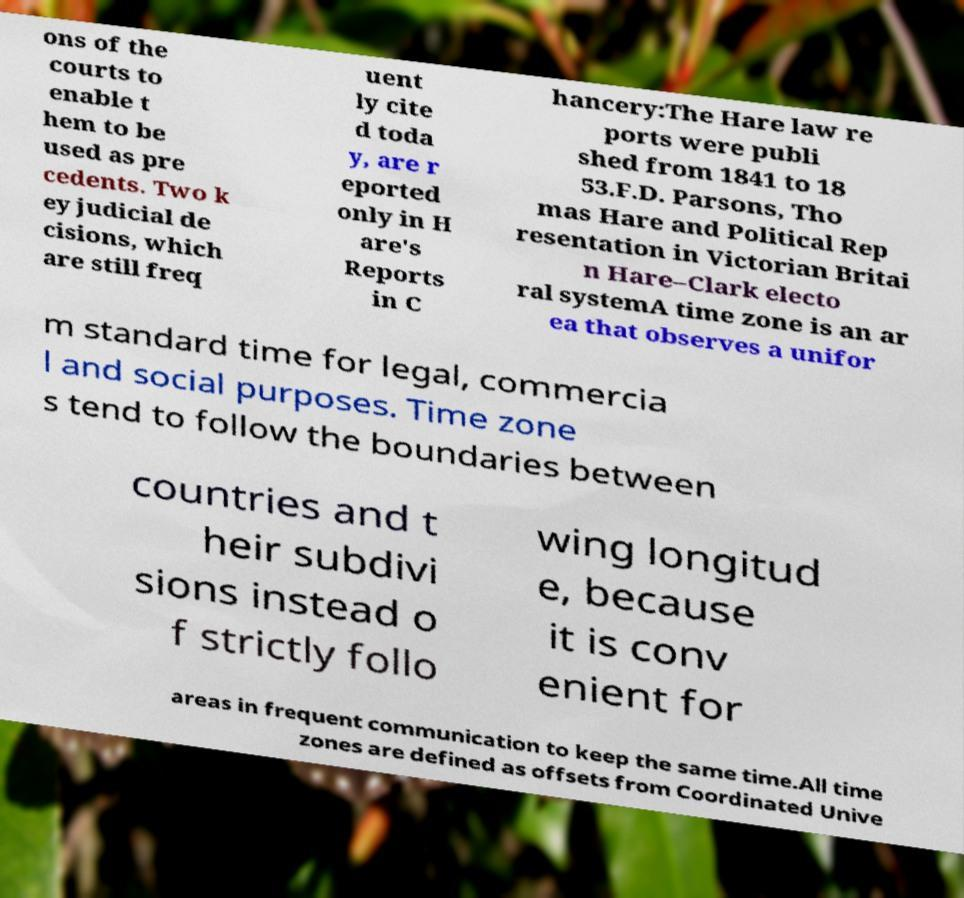I need the written content from this picture converted into text. Can you do that? ons of the courts to enable t hem to be used as pre cedents. Two k ey judicial de cisions, which are still freq uent ly cite d toda y, are r eported only in H are's Reports in C hancery:The Hare law re ports were publi shed from 1841 to 18 53.F.D. Parsons, Tho mas Hare and Political Rep resentation in Victorian Britai n Hare–Clark electo ral systemA time zone is an ar ea that observes a unifor m standard time for legal, commercia l and social purposes. Time zone s tend to follow the boundaries between countries and t heir subdivi sions instead o f strictly follo wing longitud e, because it is conv enient for areas in frequent communication to keep the same time.All time zones are defined as offsets from Coordinated Unive 